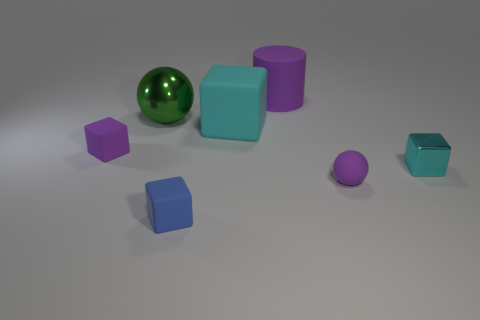The purple matte thing behind the tiny purple block has what shape?
Make the answer very short. Cylinder. Are the small purple thing to the left of the tiny purple sphere and the small block that is in front of the tiny cyan shiny cube made of the same material?
Provide a succinct answer. Yes. There is a green thing; what shape is it?
Keep it short and to the point. Sphere. Are there the same number of purple things that are in front of the tiny purple matte block and large cylinders?
Offer a terse response. Yes. There is a matte block that is the same color as the small ball; what size is it?
Your response must be concise. Small. Is there a small cyan block that has the same material as the large block?
Make the answer very short. No. There is a small purple matte object right of the large green thing; does it have the same shape as the small purple object to the left of the big cube?
Give a very brief answer. No. Is there a metal cube?
Ensure brevity in your answer.  Yes. What color is the block that is the same size as the green metal ball?
Make the answer very short. Cyan. How many green objects have the same shape as the small cyan thing?
Give a very brief answer. 0. 